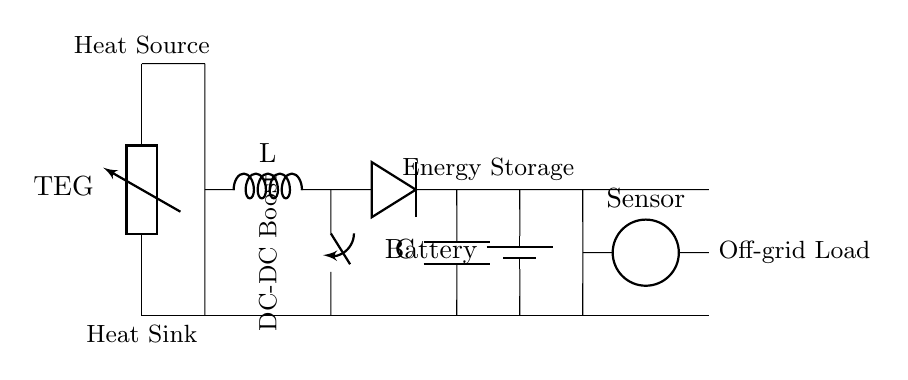What is the primary component generating power in this circuit? The primary component generating power is a thermoelectric generator (TEG), which converts temperature differences into electrical energy.
Answer: thermoelectric generator What type of converter is used in this circuit? A DC-DC boost converter is used to increase the voltage from the thermoelectric generator to a suitable level for the load.
Answer: DC-DC boost What is the role of the battery in the circuit? The battery serves as energy storage, allowing power to be supplied to the load even when the thermoelectric generator does not produce sufficient energy.
Answer: energy storage How many components are used to provide power to the sensor? Four components are used to provide power: the thermoelectric generator, the DC-DC boost converter, the battery, and the sensor itself.
Answer: four What component limits reverse current flow in the circuit? The diode limits reverse current flow, ensuring that energy only moves from the boost converter towards the battery and prevents backflow.
Answer: diode Why is the circuit designed for off-grid sensors? The circuit harnesses ambient heat and stores energy, making it suitable for off-grid environments where traditional power sources are unavailable.
Answer: ambient heat What is indicated by the heat source and heat sink in the diagram? The heat source indicates where heat enters the thermoelectric generator, while the heat sink represents the cooler side that maintains a temperature difference.
Answer: temperature difference 